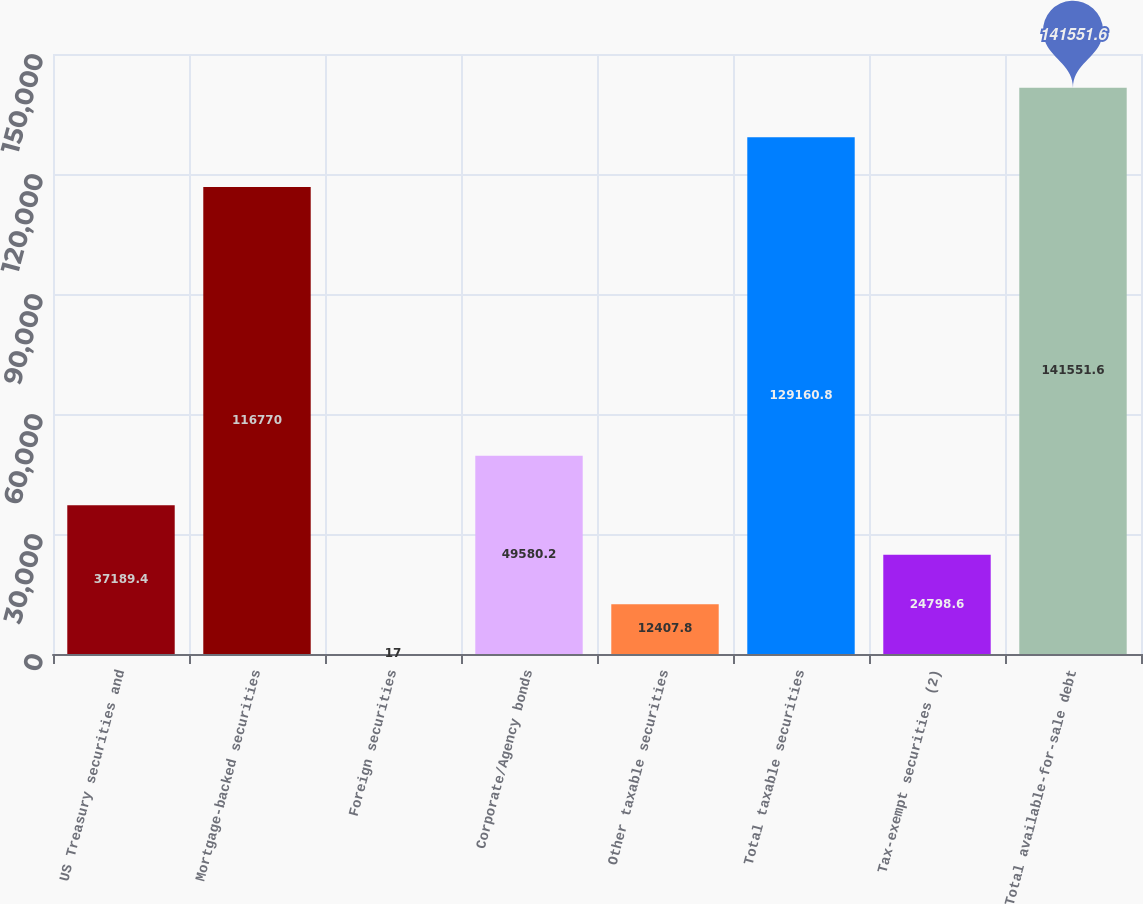Convert chart to OTSL. <chart><loc_0><loc_0><loc_500><loc_500><bar_chart><fcel>US Treasury securities and<fcel>Mortgage-backed securities<fcel>Foreign securities<fcel>Corporate/Agency bonds<fcel>Other taxable securities<fcel>Total taxable securities<fcel>Tax-exempt securities (2)<fcel>Total available-for-sale debt<nl><fcel>37189.4<fcel>116770<fcel>17<fcel>49580.2<fcel>12407.8<fcel>129161<fcel>24798.6<fcel>141552<nl></chart> 